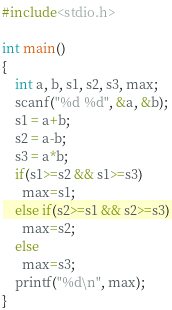Convert code to text. <code><loc_0><loc_0><loc_500><loc_500><_C_>#include<stdio.h>

int main()
{
    int a, b, s1, s2, s3, max;
    scanf("%d %d", &a, &b);
    s1 = a+b;
    s2 = a-b;
    s3 = a*b;
    if(s1>=s2 && s1>=s3)
      max=s1;
    else if(s2>=s1 && s2>=s3)
      max=s2;
    else
      max=s3;
    printf("%d\n", max);
} </code> 